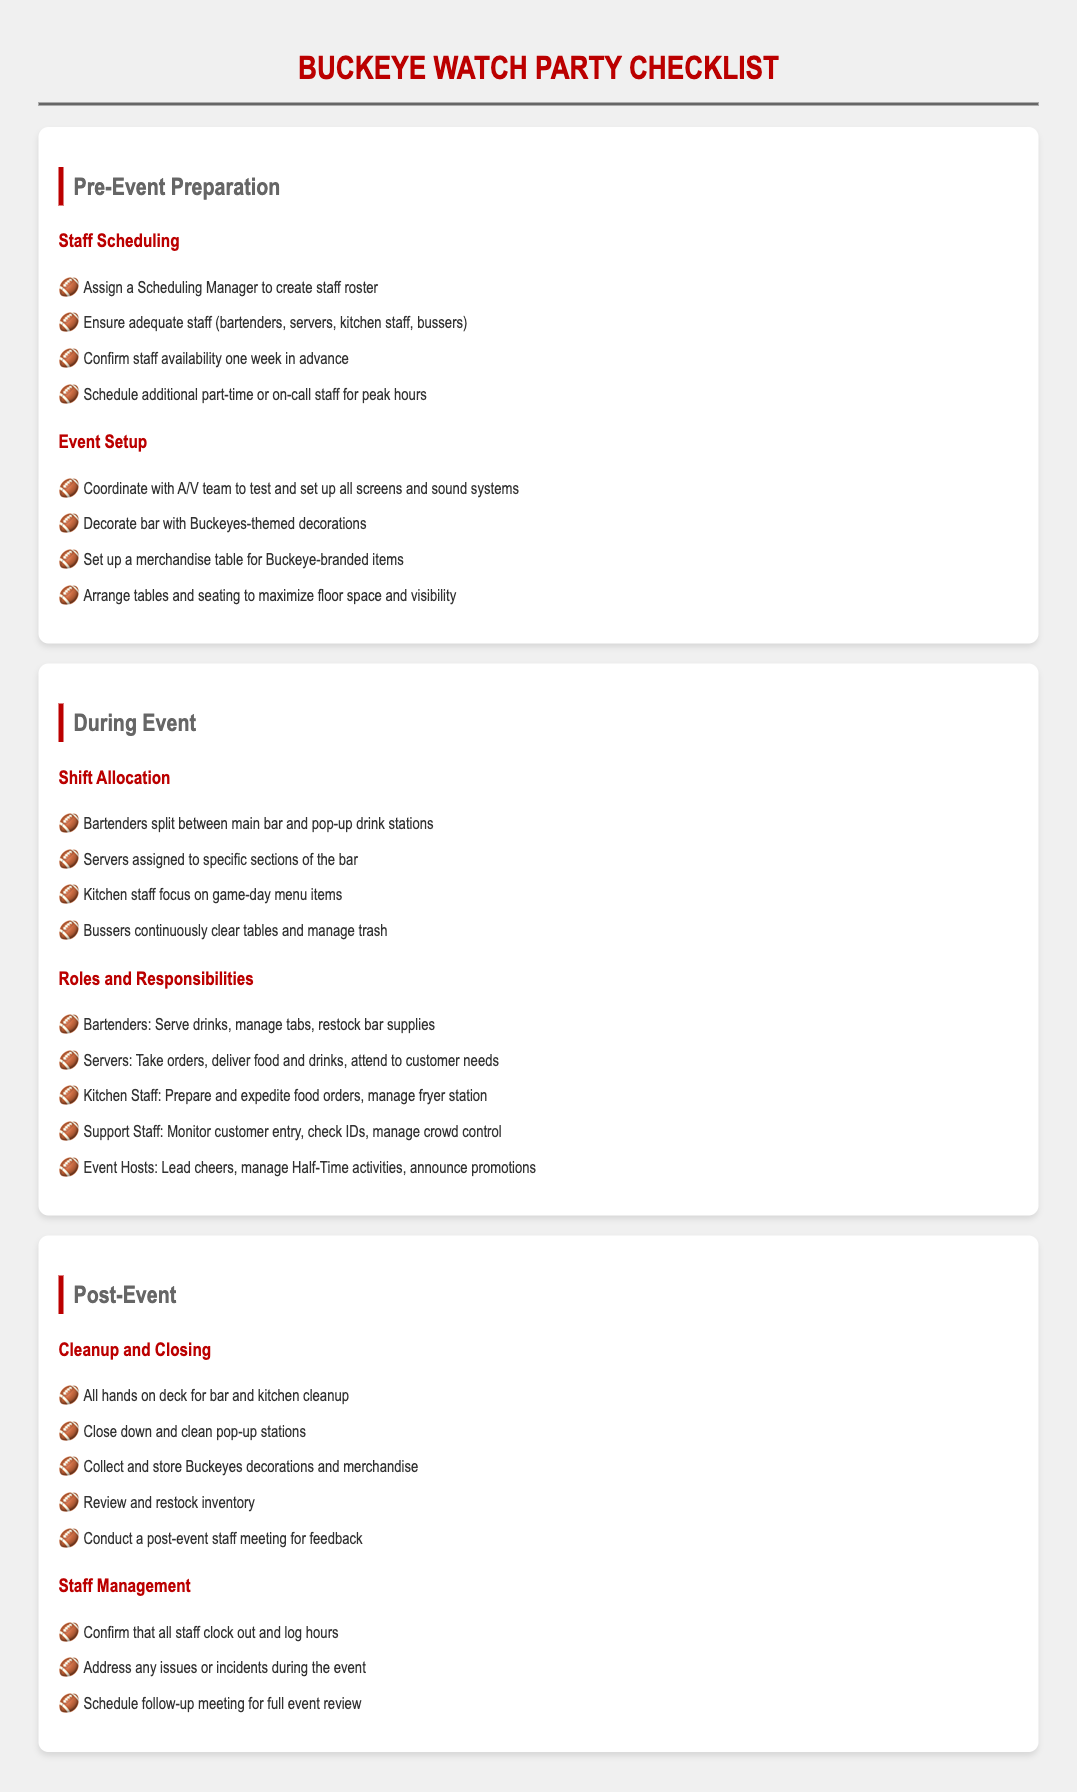What is assigned to create the staff roster? The document states that a Scheduling Manager is responsible for creating the staff roster.
Answer: Scheduling Manager How many types of staff are mentioned? The document lists four types of staff: bartenders, servers, kitchen staff, and bussers.
Answer: Four What is scheduled for one week in advance? The document mentions confirming staff availability one week in advance.
Answer: Staff availability What do bartenders manage? According to the document, bartenders manage tabs as part of their responsibilities.
Answer: Tabs What collective task is highlighted for post-event cleanup? The document states that it is an all hands on deck situation for bar and kitchen cleanup.
Answer: All hands on deck Which staff are assigned to sections of the bar? The document indicates that servers are assigned to specific sections of the bar.
Answer: Servers What materials are collected after the event? The document mentions collecting and storing Buckeyes decorations and merchandise.
Answer: Buckeyes decorations and merchandise How many responsibilities do kitchen staff have listed? The document lists two responsibilities for kitchen staff: preparing and expediting food orders and managing fryer station.
Answer: Two What is the role of event hosts during the event? Event hosts are responsible for leading cheers, managing Half-Time activities, and announcing promotions.
Answer: Leading cheers What happens during the follow-up after the event? The document states that a follow-up meeting for a full event review is scheduled.
Answer: Full event review 